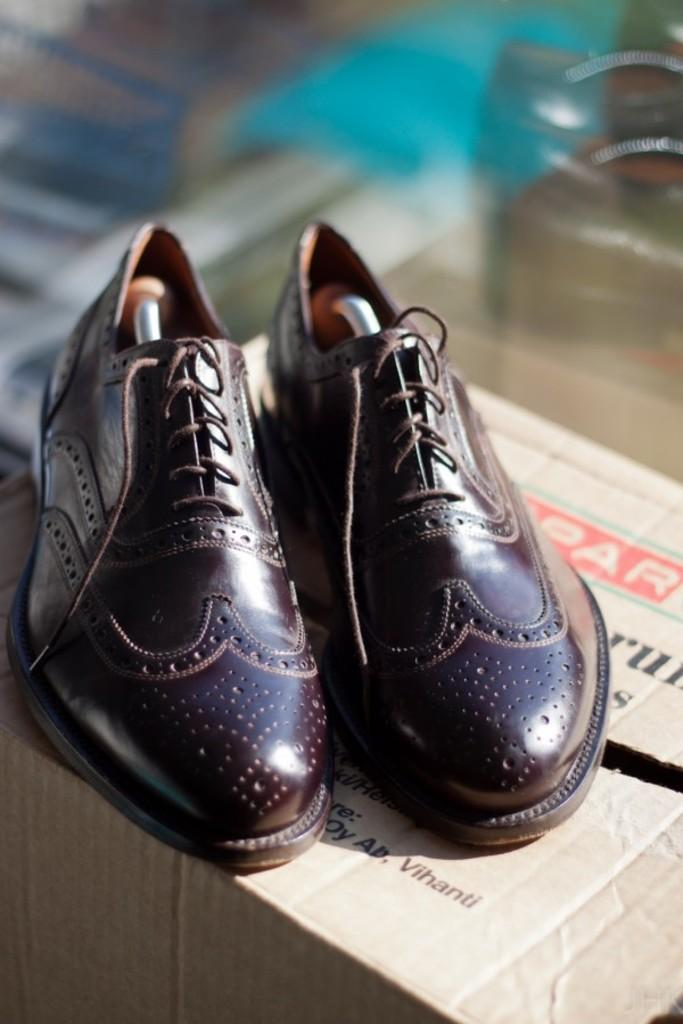What is the main object in the image? There is a pair of shoes in the image. Where are the shoes placed? The shoes are on a carton box. Can you describe the background of the image? The background of the image is blurred. What type of fork can be seen in the image? There is no fork present in the image. Can you describe the park visible in the image? There is no park present in the image. 